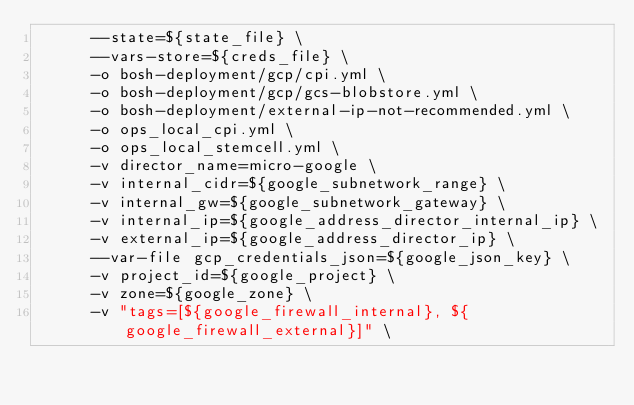<code> <loc_0><loc_0><loc_500><loc_500><_Bash_>      --state=${state_file} \
      --vars-store=${creds_file} \
      -o bosh-deployment/gcp/cpi.yml \
      -o bosh-deployment/gcp/gcs-blobstore.yml \
      -o bosh-deployment/external-ip-not-recommended.yml \
      -o ops_local_cpi.yml \
      -o ops_local_stemcell.yml \
      -v director_name=micro-google \
      -v internal_cidr=${google_subnetwork_range} \
      -v internal_gw=${google_subnetwork_gateway} \
      -v internal_ip=${google_address_director_internal_ip} \
      -v external_ip=${google_address_director_ip} \
      --var-file gcp_credentials_json=${google_json_key} \
      -v project_id=${google_project} \
      -v zone=${google_zone} \
      -v "tags=[${google_firewall_internal}, ${google_firewall_external}]" \</code> 